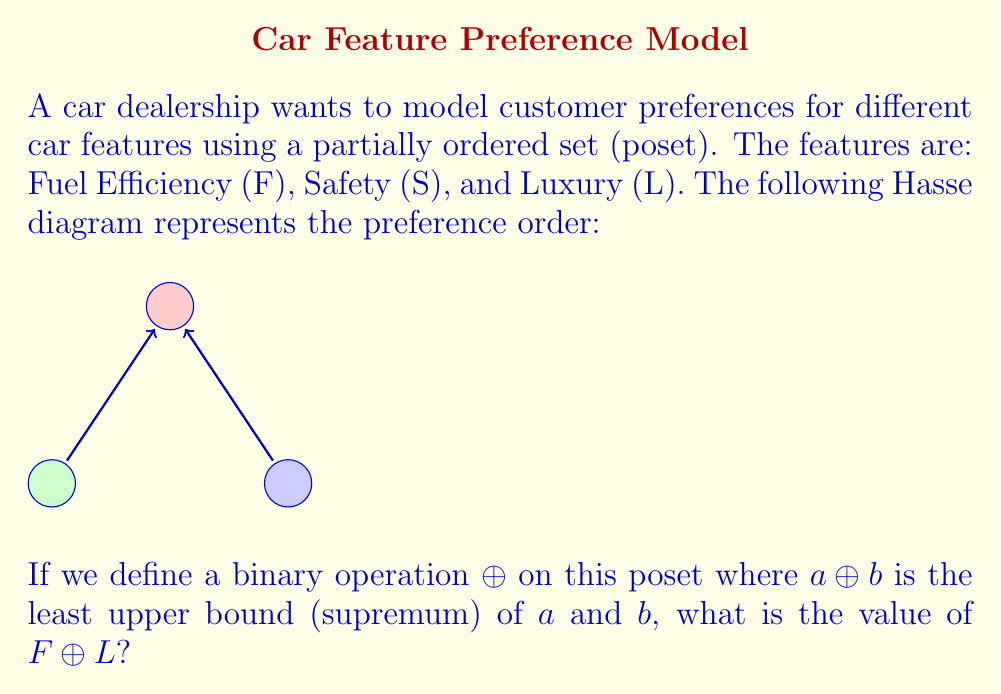Can you solve this math problem? Let's approach this step-by-step:

1) First, we need to understand what the Hasse diagram represents. In this poset:
   - S is above both F and L, indicating that S is preferred over both F and L.
   - F and L are not connected directly, meaning they are incomparable.

2) The operation $\oplus$ is defined as the least upper bound (supremum) of two elements. This means we need to find the lowest element in the poset that is greater than or equal to both operands.

3) To find $F \oplus L$, we need to identify the least upper bound of F and L.

4) Looking at the diagram:
   - F is not above L, and L is not above F.
   - The only element above both F and L is S.

5) Therefore, S is the least upper bound of F and L.

6) Thus, $F \oplus L = S$

This operation models how a customer might choose between two features, always preferring the feature that ranks higher in their overall preference structure.
Answer: $S$ 